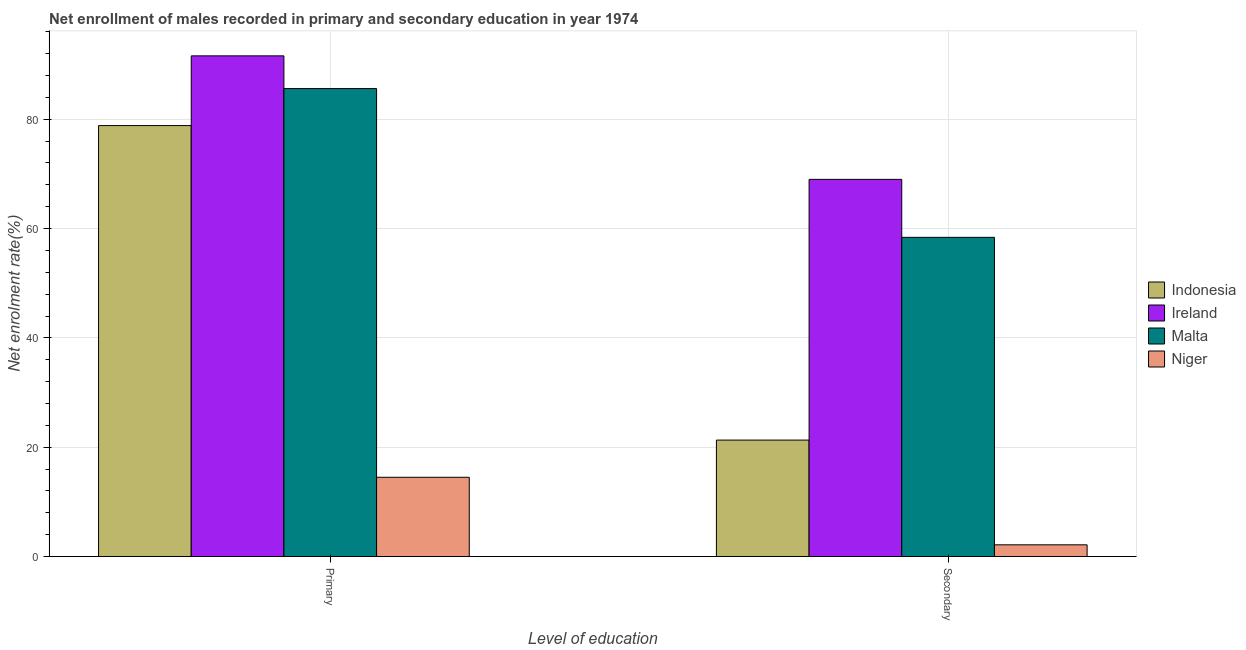How many different coloured bars are there?
Your answer should be compact. 4. How many groups of bars are there?
Ensure brevity in your answer.  2. Are the number of bars per tick equal to the number of legend labels?
Offer a terse response. Yes. Are the number of bars on each tick of the X-axis equal?
Your answer should be very brief. Yes. How many bars are there on the 2nd tick from the right?
Your response must be concise. 4. What is the label of the 1st group of bars from the left?
Your response must be concise. Primary. What is the enrollment rate in primary education in Ireland?
Offer a very short reply. 91.59. Across all countries, what is the maximum enrollment rate in secondary education?
Your answer should be compact. 69. Across all countries, what is the minimum enrollment rate in primary education?
Give a very brief answer. 14.5. In which country was the enrollment rate in secondary education maximum?
Provide a short and direct response. Ireland. In which country was the enrollment rate in primary education minimum?
Your answer should be very brief. Niger. What is the total enrollment rate in primary education in the graph?
Provide a short and direct response. 270.54. What is the difference between the enrollment rate in secondary education in Niger and that in Malta?
Offer a terse response. -56.25. What is the difference between the enrollment rate in primary education in Indonesia and the enrollment rate in secondary education in Malta?
Give a very brief answer. 20.44. What is the average enrollment rate in secondary education per country?
Your answer should be compact. 37.71. What is the difference between the enrollment rate in secondary education and enrollment rate in primary education in Indonesia?
Offer a very short reply. -57.54. In how many countries, is the enrollment rate in secondary education greater than 48 %?
Give a very brief answer. 2. What is the ratio of the enrollment rate in primary education in Malta to that in Indonesia?
Keep it short and to the point. 1.09. What does the 3rd bar from the left in Secondary represents?
Ensure brevity in your answer.  Malta. How many bars are there?
Provide a succinct answer. 8. Are all the bars in the graph horizontal?
Ensure brevity in your answer.  No. How many countries are there in the graph?
Keep it short and to the point. 4. Does the graph contain grids?
Provide a short and direct response. Yes. How are the legend labels stacked?
Offer a very short reply. Vertical. What is the title of the graph?
Provide a succinct answer. Net enrollment of males recorded in primary and secondary education in year 1974. What is the label or title of the X-axis?
Offer a very short reply. Level of education. What is the label or title of the Y-axis?
Your response must be concise. Net enrolment rate(%). What is the Net enrolment rate(%) of Indonesia in Primary?
Provide a short and direct response. 78.84. What is the Net enrolment rate(%) of Ireland in Primary?
Keep it short and to the point. 91.59. What is the Net enrolment rate(%) of Malta in Primary?
Keep it short and to the point. 85.61. What is the Net enrolment rate(%) of Niger in Primary?
Ensure brevity in your answer.  14.5. What is the Net enrolment rate(%) of Indonesia in Secondary?
Offer a very short reply. 21.3. What is the Net enrolment rate(%) of Ireland in Secondary?
Offer a terse response. 69. What is the Net enrolment rate(%) in Malta in Secondary?
Make the answer very short. 58.39. What is the Net enrolment rate(%) in Niger in Secondary?
Offer a terse response. 2.14. Across all Level of education, what is the maximum Net enrolment rate(%) in Indonesia?
Your response must be concise. 78.84. Across all Level of education, what is the maximum Net enrolment rate(%) of Ireland?
Offer a very short reply. 91.59. Across all Level of education, what is the maximum Net enrolment rate(%) of Malta?
Your answer should be compact. 85.61. Across all Level of education, what is the maximum Net enrolment rate(%) of Niger?
Offer a terse response. 14.5. Across all Level of education, what is the minimum Net enrolment rate(%) in Indonesia?
Provide a succinct answer. 21.3. Across all Level of education, what is the minimum Net enrolment rate(%) of Ireland?
Make the answer very short. 69. Across all Level of education, what is the minimum Net enrolment rate(%) in Malta?
Your answer should be compact. 58.39. Across all Level of education, what is the minimum Net enrolment rate(%) of Niger?
Keep it short and to the point. 2.14. What is the total Net enrolment rate(%) of Indonesia in the graph?
Offer a terse response. 100.14. What is the total Net enrolment rate(%) in Ireland in the graph?
Ensure brevity in your answer.  160.59. What is the total Net enrolment rate(%) of Malta in the graph?
Offer a very short reply. 144.01. What is the total Net enrolment rate(%) of Niger in the graph?
Your response must be concise. 16.64. What is the difference between the Net enrolment rate(%) of Indonesia in Primary and that in Secondary?
Your answer should be compact. 57.54. What is the difference between the Net enrolment rate(%) of Ireland in Primary and that in Secondary?
Give a very brief answer. 22.6. What is the difference between the Net enrolment rate(%) in Malta in Primary and that in Secondary?
Offer a very short reply. 27.22. What is the difference between the Net enrolment rate(%) of Niger in Primary and that in Secondary?
Offer a very short reply. 12.36. What is the difference between the Net enrolment rate(%) of Indonesia in Primary and the Net enrolment rate(%) of Ireland in Secondary?
Make the answer very short. 9.84. What is the difference between the Net enrolment rate(%) in Indonesia in Primary and the Net enrolment rate(%) in Malta in Secondary?
Offer a terse response. 20.44. What is the difference between the Net enrolment rate(%) in Indonesia in Primary and the Net enrolment rate(%) in Niger in Secondary?
Your response must be concise. 76.7. What is the difference between the Net enrolment rate(%) of Ireland in Primary and the Net enrolment rate(%) of Malta in Secondary?
Your answer should be compact. 33.2. What is the difference between the Net enrolment rate(%) in Ireland in Primary and the Net enrolment rate(%) in Niger in Secondary?
Make the answer very short. 89.45. What is the difference between the Net enrolment rate(%) of Malta in Primary and the Net enrolment rate(%) of Niger in Secondary?
Ensure brevity in your answer.  83.47. What is the average Net enrolment rate(%) in Indonesia per Level of education?
Provide a succinct answer. 50.07. What is the average Net enrolment rate(%) of Ireland per Level of education?
Your response must be concise. 80.3. What is the average Net enrolment rate(%) of Malta per Level of education?
Give a very brief answer. 72. What is the average Net enrolment rate(%) of Niger per Level of education?
Give a very brief answer. 8.32. What is the difference between the Net enrolment rate(%) in Indonesia and Net enrolment rate(%) in Ireland in Primary?
Provide a succinct answer. -12.76. What is the difference between the Net enrolment rate(%) of Indonesia and Net enrolment rate(%) of Malta in Primary?
Give a very brief answer. -6.77. What is the difference between the Net enrolment rate(%) of Indonesia and Net enrolment rate(%) of Niger in Primary?
Keep it short and to the point. 64.34. What is the difference between the Net enrolment rate(%) of Ireland and Net enrolment rate(%) of Malta in Primary?
Your answer should be very brief. 5.98. What is the difference between the Net enrolment rate(%) in Ireland and Net enrolment rate(%) in Niger in Primary?
Give a very brief answer. 77.1. What is the difference between the Net enrolment rate(%) in Malta and Net enrolment rate(%) in Niger in Primary?
Make the answer very short. 71.11. What is the difference between the Net enrolment rate(%) in Indonesia and Net enrolment rate(%) in Ireland in Secondary?
Your answer should be very brief. -47.7. What is the difference between the Net enrolment rate(%) of Indonesia and Net enrolment rate(%) of Malta in Secondary?
Ensure brevity in your answer.  -37.09. What is the difference between the Net enrolment rate(%) in Indonesia and Net enrolment rate(%) in Niger in Secondary?
Give a very brief answer. 19.16. What is the difference between the Net enrolment rate(%) in Ireland and Net enrolment rate(%) in Malta in Secondary?
Provide a short and direct response. 10.6. What is the difference between the Net enrolment rate(%) in Ireland and Net enrolment rate(%) in Niger in Secondary?
Ensure brevity in your answer.  66.86. What is the difference between the Net enrolment rate(%) in Malta and Net enrolment rate(%) in Niger in Secondary?
Your answer should be very brief. 56.25. What is the ratio of the Net enrolment rate(%) in Indonesia in Primary to that in Secondary?
Give a very brief answer. 3.7. What is the ratio of the Net enrolment rate(%) of Ireland in Primary to that in Secondary?
Ensure brevity in your answer.  1.33. What is the ratio of the Net enrolment rate(%) of Malta in Primary to that in Secondary?
Offer a very short reply. 1.47. What is the ratio of the Net enrolment rate(%) in Niger in Primary to that in Secondary?
Provide a short and direct response. 6.77. What is the difference between the highest and the second highest Net enrolment rate(%) in Indonesia?
Give a very brief answer. 57.54. What is the difference between the highest and the second highest Net enrolment rate(%) in Ireland?
Offer a very short reply. 22.6. What is the difference between the highest and the second highest Net enrolment rate(%) in Malta?
Offer a very short reply. 27.22. What is the difference between the highest and the second highest Net enrolment rate(%) of Niger?
Make the answer very short. 12.36. What is the difference between the highest and the lowest Net enrolment rate(%) in Indonesia?
Offer a terse response. 57.54. What is the difference between the highest and the lowest Net enrolment rate(%) in Ireland?
Your answer should be compact. 22.6. What is the difference between the highest and the lowest Net enrolment rate(%) in Malta?
Give a very brief answer. 27.22. What is the difference between the highest and the lowest Net enrolment rate(%) in Niger?
Your response must be concise. 12.36. 